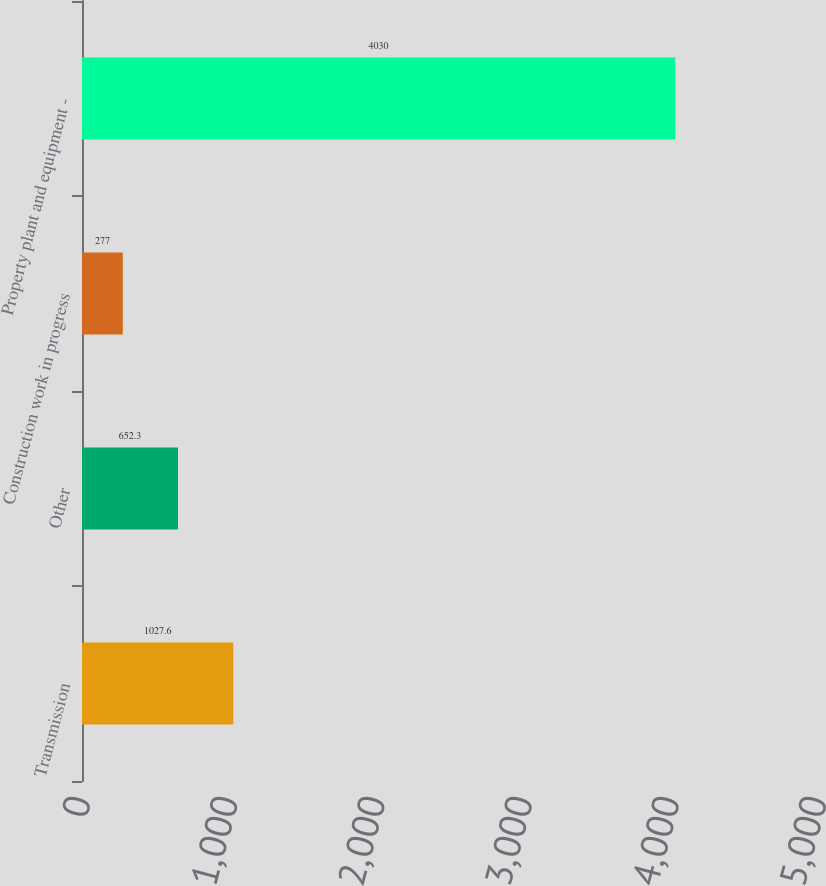Convert chart. <chart><loc_0><loc_0><loc_500><loc_500><bar_chart><fcel>Transmission<fcel>Other<fcel>Construction work in progress<fcel>Property plant and equipment -<nl><fcel>1027.6<fcel>652.3<fcel>277<fcel>4030<nl></chart> 